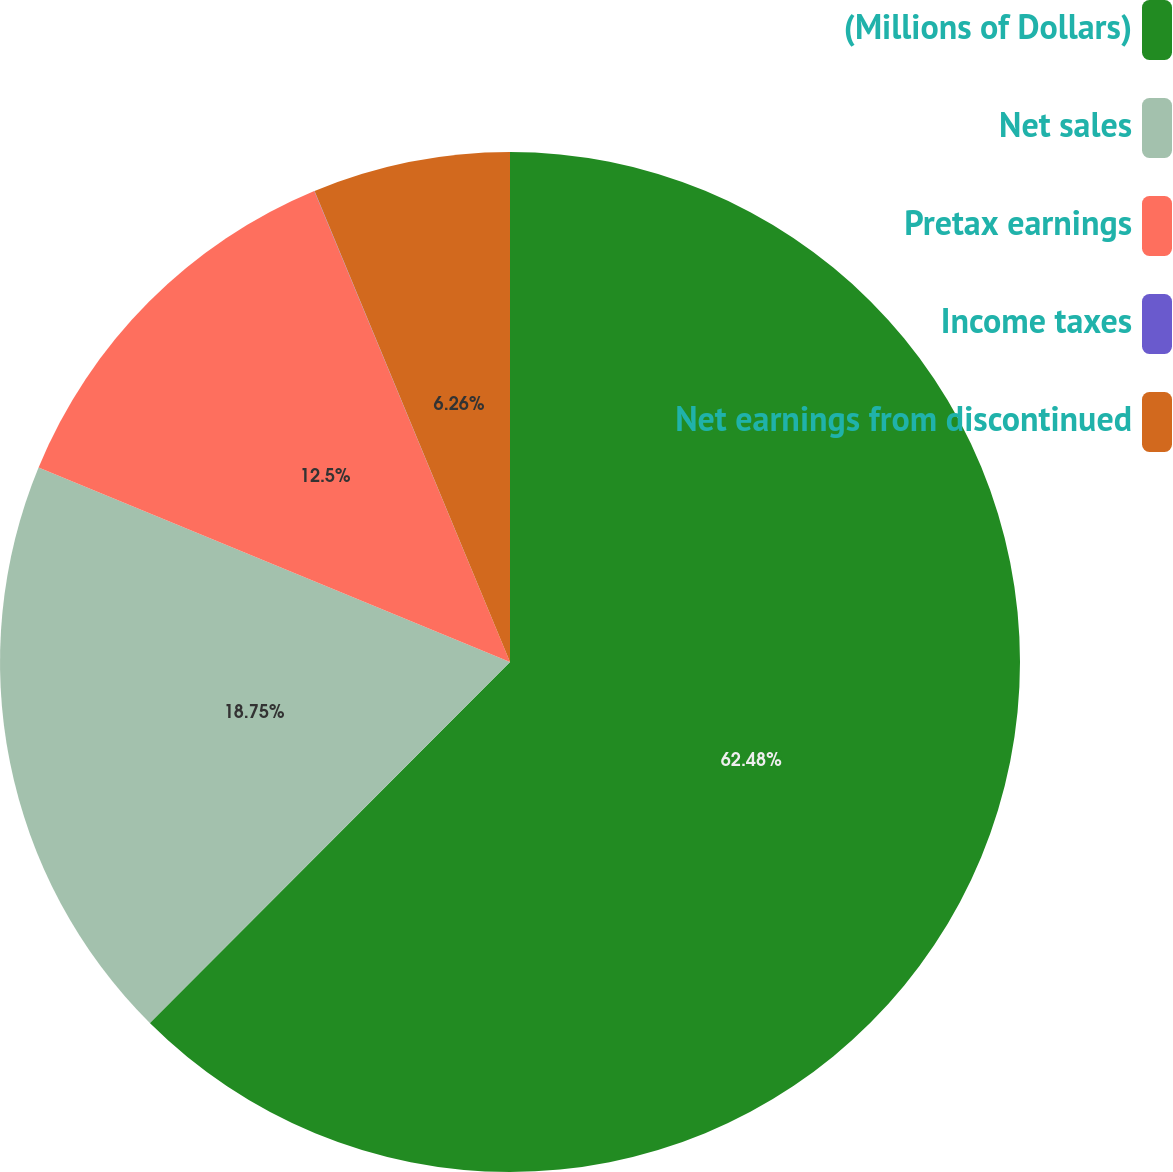Convert chart to OTSL. <chart><loc_0><loc_0><loc_500><loc_500><pie_chart><fcel>(Millions of Dollars)<fcel>Net sales<fcel>Pretax earnings<fcel>Income taxes<fcel>Net earnings from discontinued<nl><fcel>62.48%<fcel>18.75%<fcel>12.5%<fcel>0.01%<fcel>6.26%<nl></chart> 